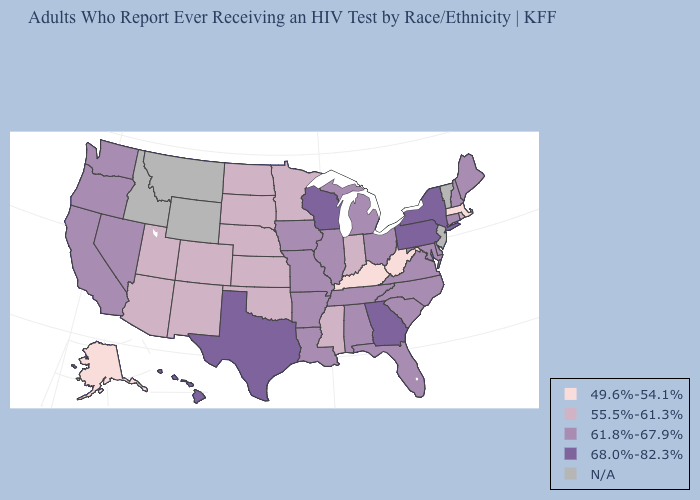Does Hawaii have the highest value in the USA?
Give a very brief answer. Yes. Does Kansas have the lowest value in the MidWest?
Keep it brief. Yes. What is the highest value in the South ?
Short answer required. 68.0%-82.3%. Name the states that have a value in the range 61.8%-67.9%?
Be succinct. Alabama, Arkansas, California, Connecticut, Delaware, Florida, Illinois, Iowa, Louisiana, Maine, Maryland, Michigan, Missouri, Nevada, New Hampshire, North Carolina, Ohio, Oregon, South Carolina, Tennessee, Virginia, Washington. Name the states that have a value in the range 61.8%-67.9%?
Write a very short answer. Alabama, Arkansas, California, Connecticut, Delaware, Florida, Illinois, Iowa, Louisiana, Maine, Maryland, Michigan, Missouri, Nevada, New Hampshire, North Carolina, Ohio, Oregon, South Carolina, Tennessee, Virginia, Washington. What is the value of North Dakota?
Answer briefly. 55.5%-61.3%. Is the legend a continuous bar?
Quick response, please. No. What is the highest value in the West ?
Quick response, please. 68.0%-82.3%. What is the highest value in the West ?
Short answer required. 68.0%-82.3%. Does Alabama have the highest value in the USA?
Short answer required. No. Does New York have the highest value in the Northeast?
Give a very brief answer. Yes. Name the states that have a value in the range 55.5%-61.3%?
Concise answer only. Arizona, Colorado, Indiana, Kansas, Minnesota, Mississippi, Nebraska, New Mexico, North Dakota, Oklahoma, Rhode Island, South Dakota, Utah. Among the states that border Florida , which have the lowest value?
Be succinct. Alabama. Name the states that have a value in the range 61.8%-67.9%?
Short answer required. Alabama, Arkansas, California, Connecticut, Delaware, Florida, Illinois, Iowa, Louisiana, Maine, Maryland, Michigan, Missouri, Nevada, New Hampshire, North Carolina, Ohio, Oregon, South Carolina, Tennessee, Virginia, Washington. What is the lowest value in states that border Tennessee?
Be succinct. 49.6%-54.1%. 